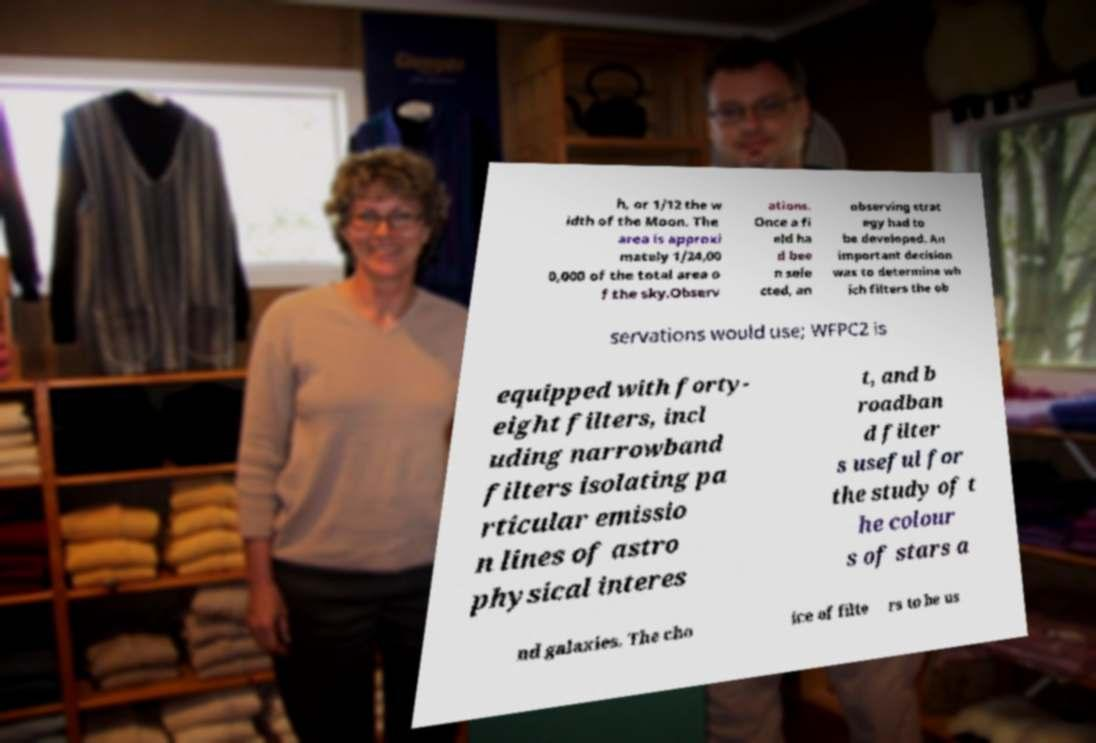For documentation purposes, I need the text within this image transcribed. Could you provide that? h, or 1/12 the w idth of the Moon. The area is approxi mately 1/24,00 0,000 of the total area o f the sky.Observ ations. Once a fi eld ha d bee n sele cted, an observing strat egy had to be developed. An important decision was to determine wh ich filters the ob servations would use; WFPC2 is equipped with forty- eight filters, incl uding narrowband filters isolating pa rticular emissio n lines of astro physical interes t, and b roadban d filter s useful for the study of t he colour s of stars a nd galaxies. The cho ice of filte rs to be us 